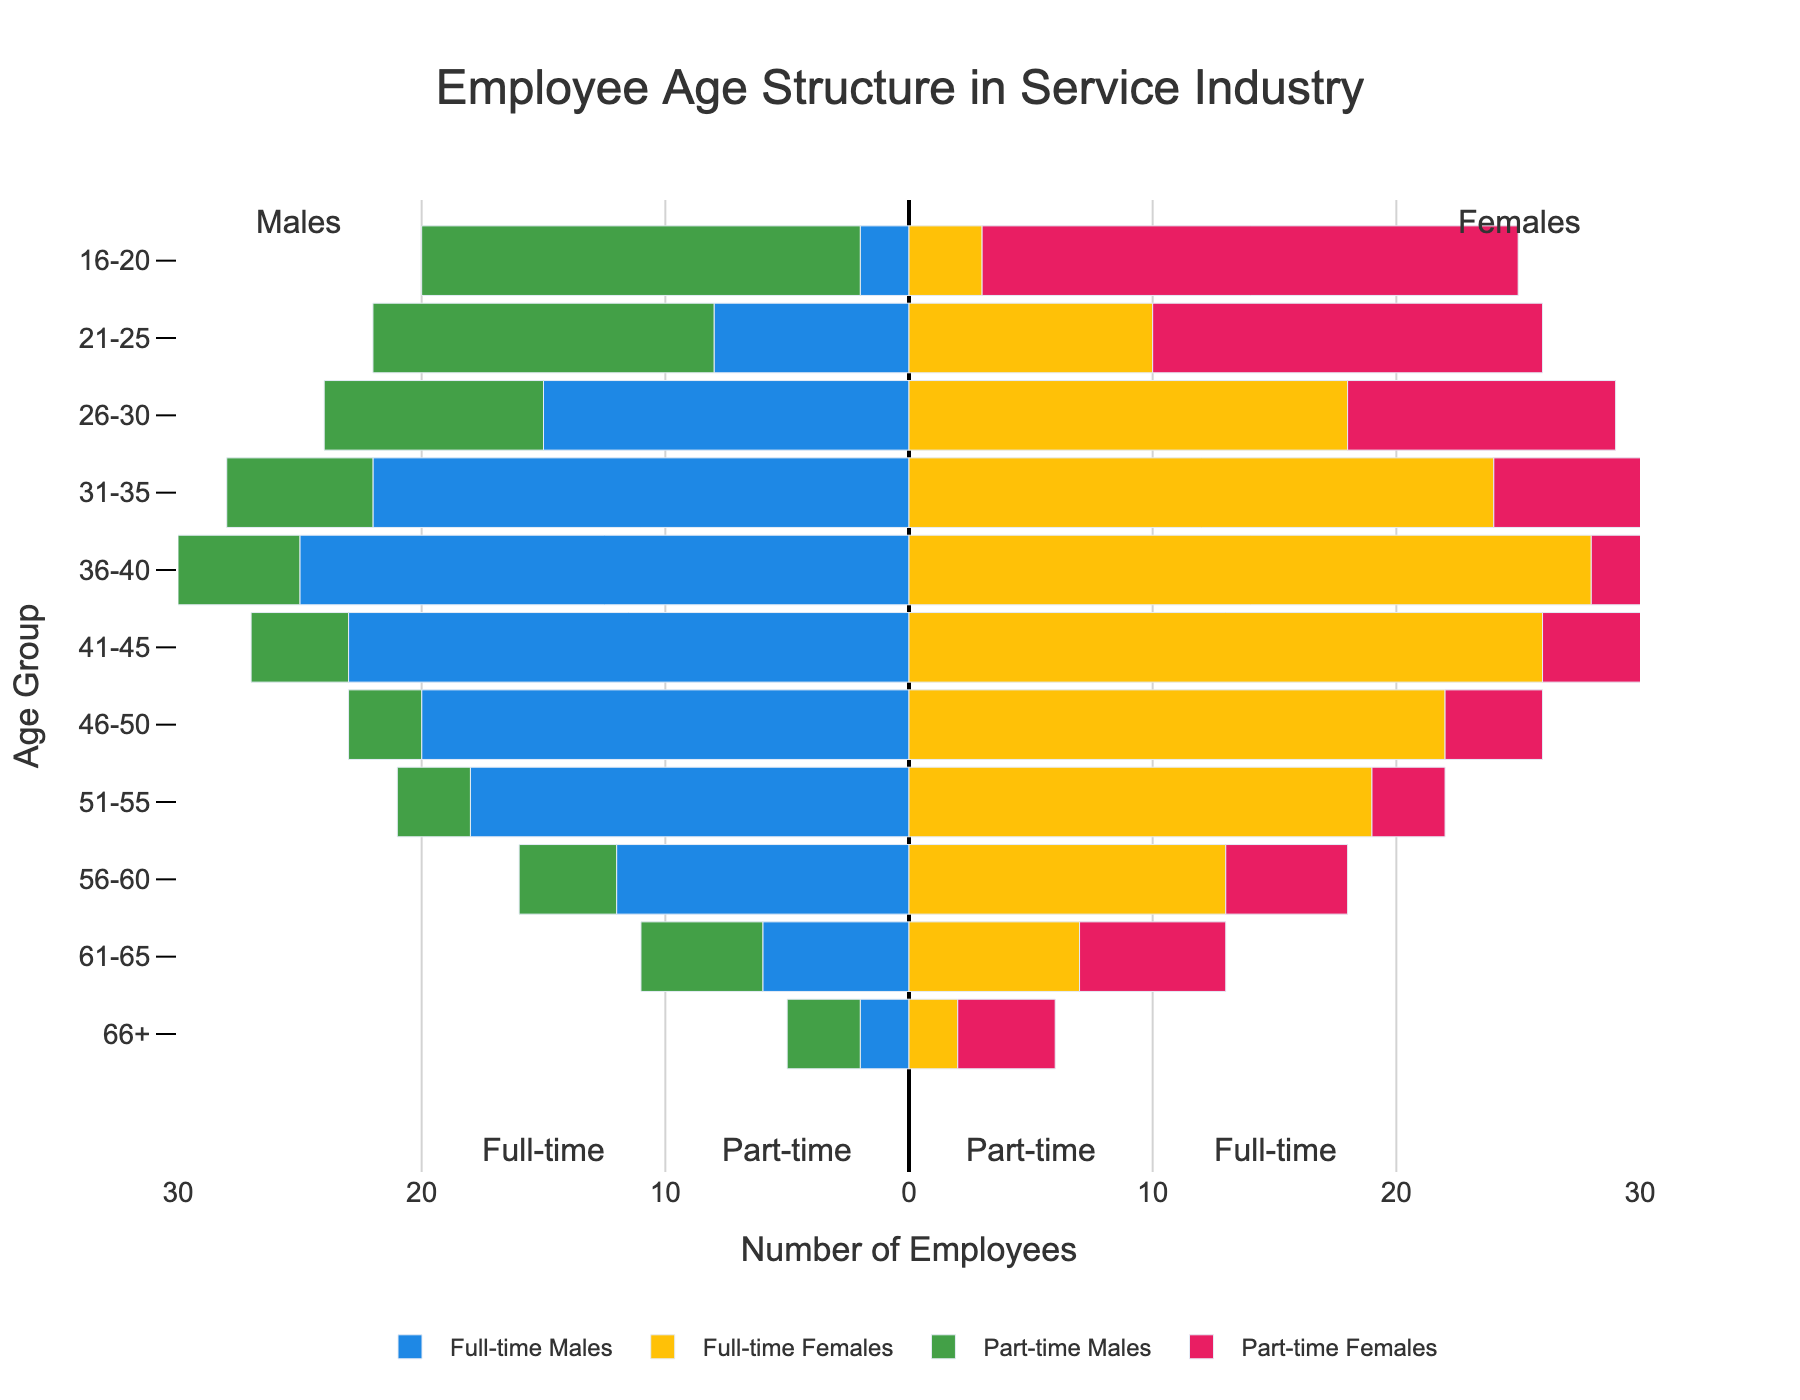What is the title of the figure? The title of the figure is positioned at the top and provides a summary of the figure's content. It reads: "Employee Age Structure in Service Industry".
Answer: Employee Age Structure in Service Industry What are the colors used to represent full-time males and full-time females? The colors used for full-time males and females are distinguishable on the plot. Full-time males are represented by blue bars, and full-time females are represented by yellow bars.
Answer: Blue for full-time males and yellow for full-time females Which age group has the highest number of full-time female employees? By examining the lengths of the bars on the plot, the longest yellow bar indicates the age group with the highest number of full-time female employees. This is the 36-40 age group with 28 employees.
Answer: 36-40 How many part-time male employees are there in the 56-60 age group, and how does that compare to the number of part-time female employees in the same age group? The plot shows that the length of the green and pink bars for the 56-60 age group represents the number of part-time male and female employees. There are 4 part-time males and 5 part-time females in this age group.
Answer: 4 part-time males and 5 part-time females What is the total number of part-time workers in the 46-50 age group? To find the total number of part-time workers in the 46-50 age group, sum the values from the green and pink bars. There are 3 part-time males and 4 part-time females, so the total is 3 + 4 = 7.
Answer: 7 Which group has a larger share of employees aged 21-25: part-time workers or full-time workers? By comparing the lengths of the relevant bars for the 21-25 age group, the combined green and pink bars (part-time) are shorter than the combined blue and yellow bars (full-time). Full-time workers have more employees aged 21-25.
Answer: Full-time workers What is the difference in the number of full-time male employees between the age groups 36-40 and 66+? The full-time male bars for the 36-40 age group and the 66+ age group need to be compared. The number of full-time males in the 36-40 age group is 25, while in the 66+ age group, it is 2. The difference is 25 - 2 = 23.
Answer: 23 How do the trends in full-time employment differ for males and females as age increases? Examine the blue and yellow bars across age groups. Full-time males show a rise from younger to middle age and a decline after 40. Full-time females exhibit a similar pattern but with slightly higher values in the middle age groups.
Answer: Similar rise and decline trend, with females slightly higher in middle age Which gender has the highest number of employees in the 61-65 age group for part-time work? For the 61-65 age group, the lengths of the green (part-time males) and pink (part-time females) bars indicate the number of employees. The pink bar is slightly longer, indicating more part-time females.
Answer: Females 